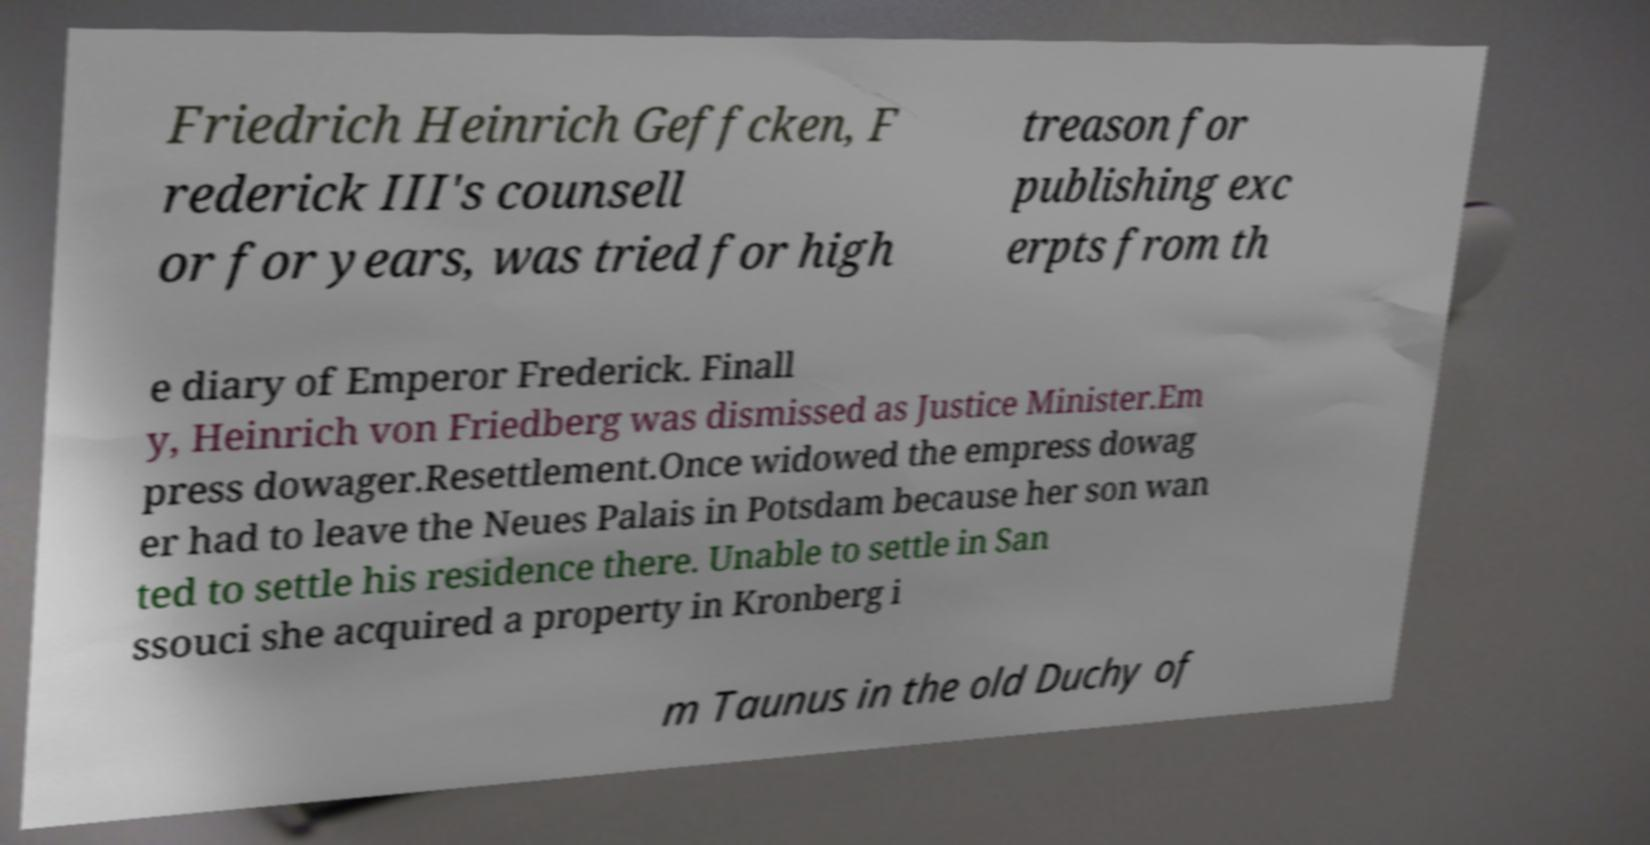Please read and relay the text visible in this image. What does it say? Friedrich Heinrich Geffcken, F rederick III's counsell or for years, was tried for high treason for publishing exc erpts from th e diary of Emperor Frederick. Finall y, Heinrich von Friedberg was dismissed as Justice Minister.Em press dowager.Resettlement.Once widowed the empress dowag er had to leave the Neues Palais in Potsdam because her son wan ted to settle his residence there. Unable to settle in San ssouci she acquired a property in Kronberg i m Taunus in the old Duchy of 